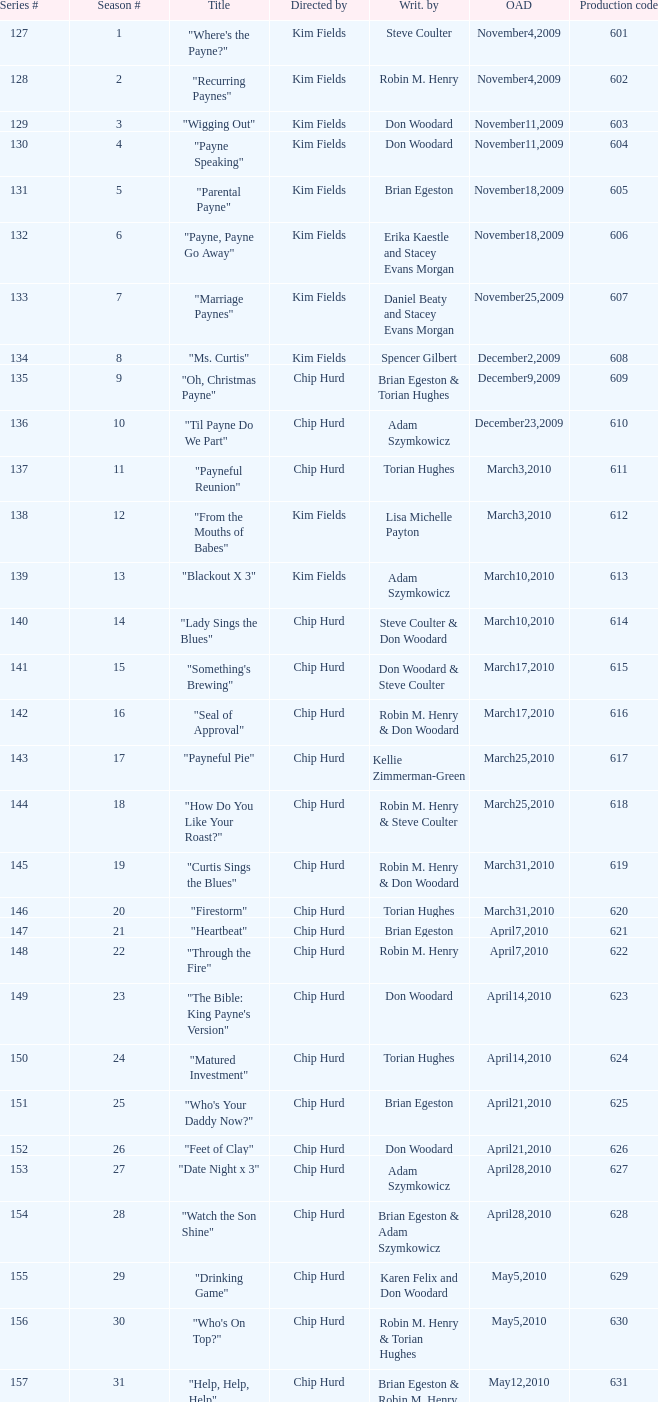What is the title of the episode with the production code 624? "Matured Investment". 